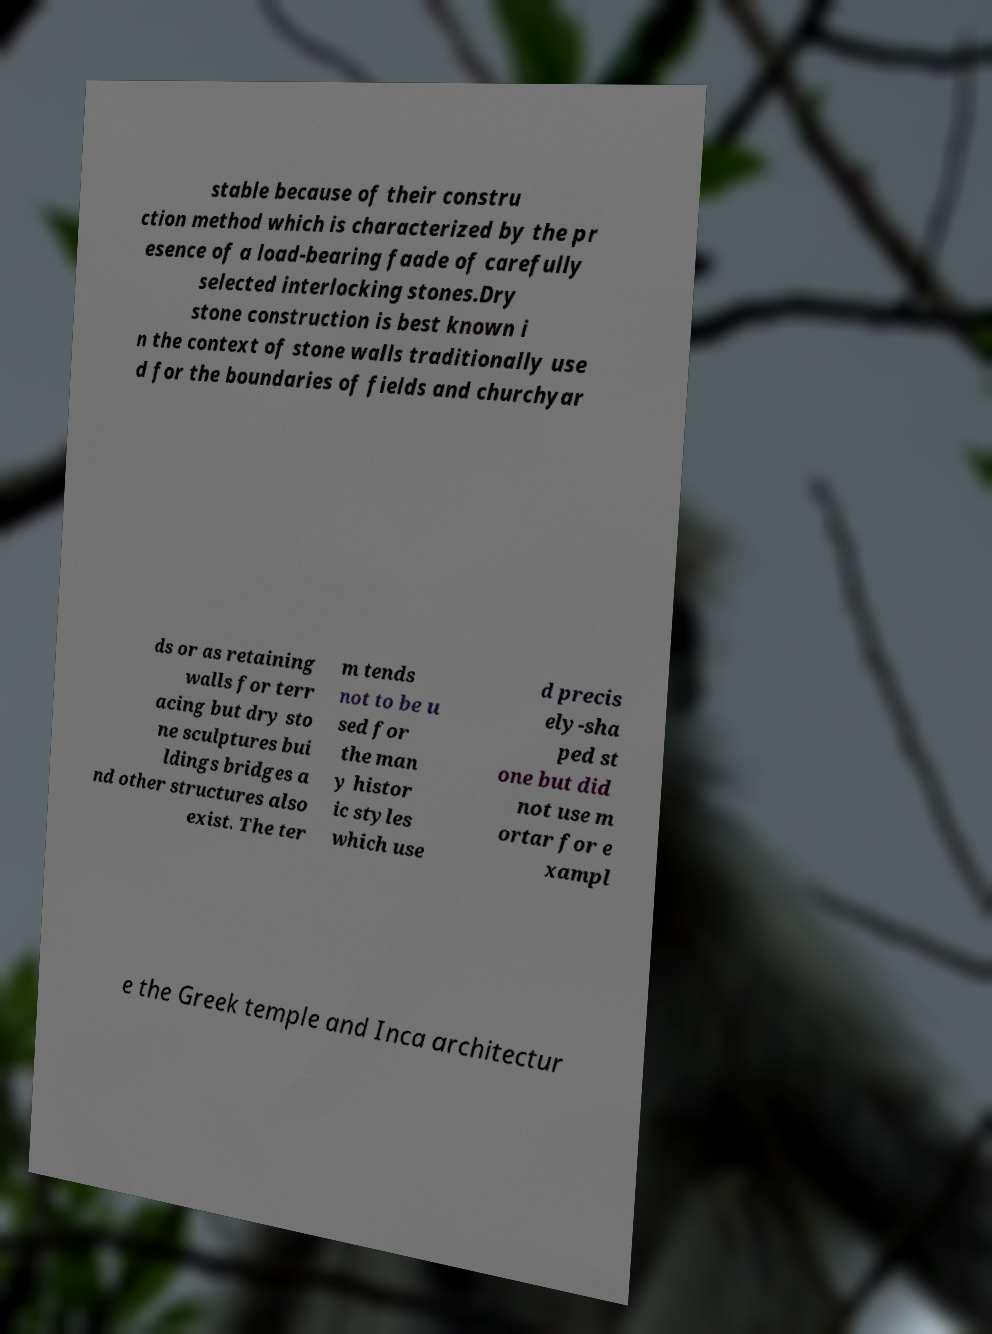Please read and relay the text visible in this image. What does it say? stable because of their constru ction method which is characterized by the pr esence of a load-bearing faade of carefully selected interlocking stones.Dry stone construction is best known i n the context of stone walls traditionally use d for the boundaries of fields and churchyar ds or as retaining walls for terr acing but dry sto ne sculptures bui ldings bridges a nd other structures also exist. The ter m tends not to be u sed for the man y histor ic styles which use d precis ely-sha ped st one but did not use m ortar for e xampl e the Greek temple and Inca architectur 